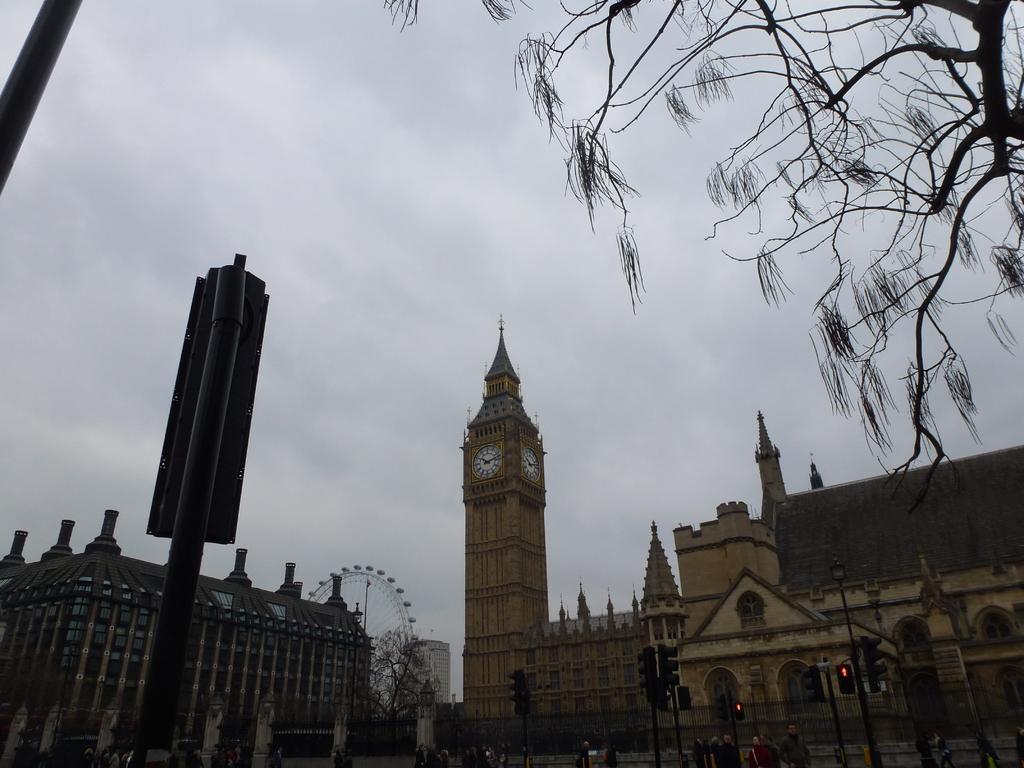How would you summarize this image in a sentence or two? Here in the middle we can see a clock tower present and beside that we can see a giant wheel and we can see buildings present on either side all over there and in the front we can see traffic signal lights present on the pole over there and we can see trees present here and there and we can see sign boards also present here and there and we can see clouds in sky over there. 